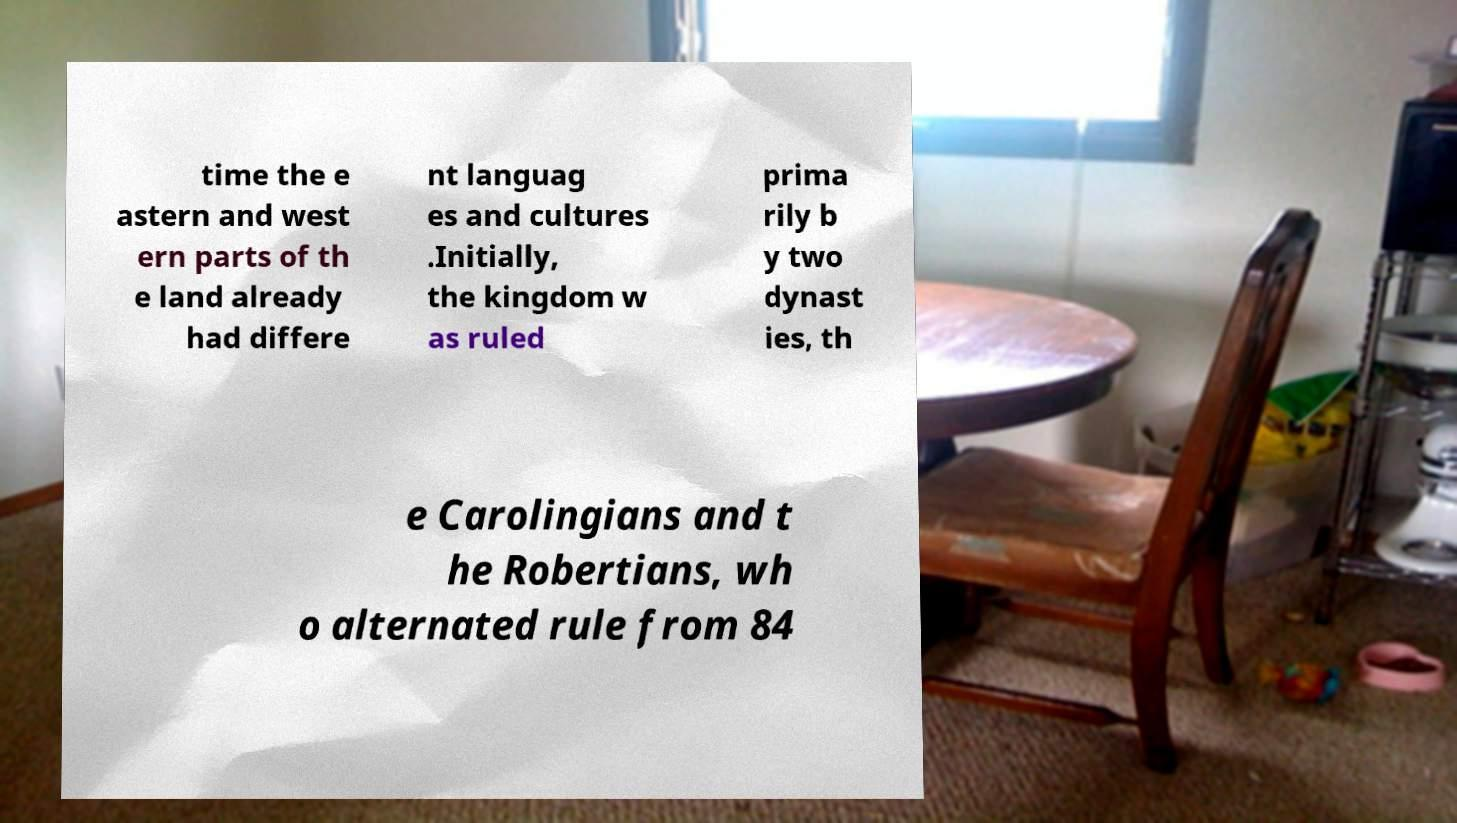Please identify and transcribe the text found in this image. time the e astern and west ern parts of th e land already had differe nt languag es and cultures .Initially, the kingdom w as ruled prima rily b y two dynast ies, th e Carolingians and t he Robertians, wh o alternated rule from 84 